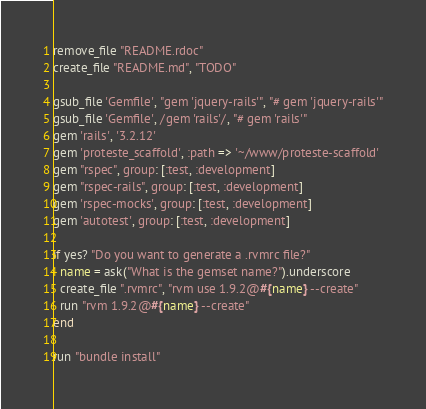Convert code to text. <code><loc_0><loc_0><loc_500><loc_500><_Ruby_>remove_file "README.rdoc"
create_file "README.md", "TODO"

gsub_file 'Gemfile', "gem 'jquery-rails'", "# gem 'jquery-rails'"
gsub_file 'Gemfile', /gem 'rails'/, "# gem 'rails'"
gem 'rails', '3.2.12'
gem 'proteste_scaffold', :path => '~/www/proteste-scaffold'
gem "rspec", group: [:test, :development]
gem "rspec-rails", group: [:test, :development]
gem 'rspec-mocks', group: [:test, :development]
gem 'autotest', group: [:test, :development]

if yes? "Do you want to generate a .rvmrc file?"
  name = ask("What is the gemset name?").underscore
  create_file ".rvmrc", "rvm use 1.9.2@#{name} --create"
  run "rvm 1.9.2@#{name} --create"
end

run "bundle install"</code> 